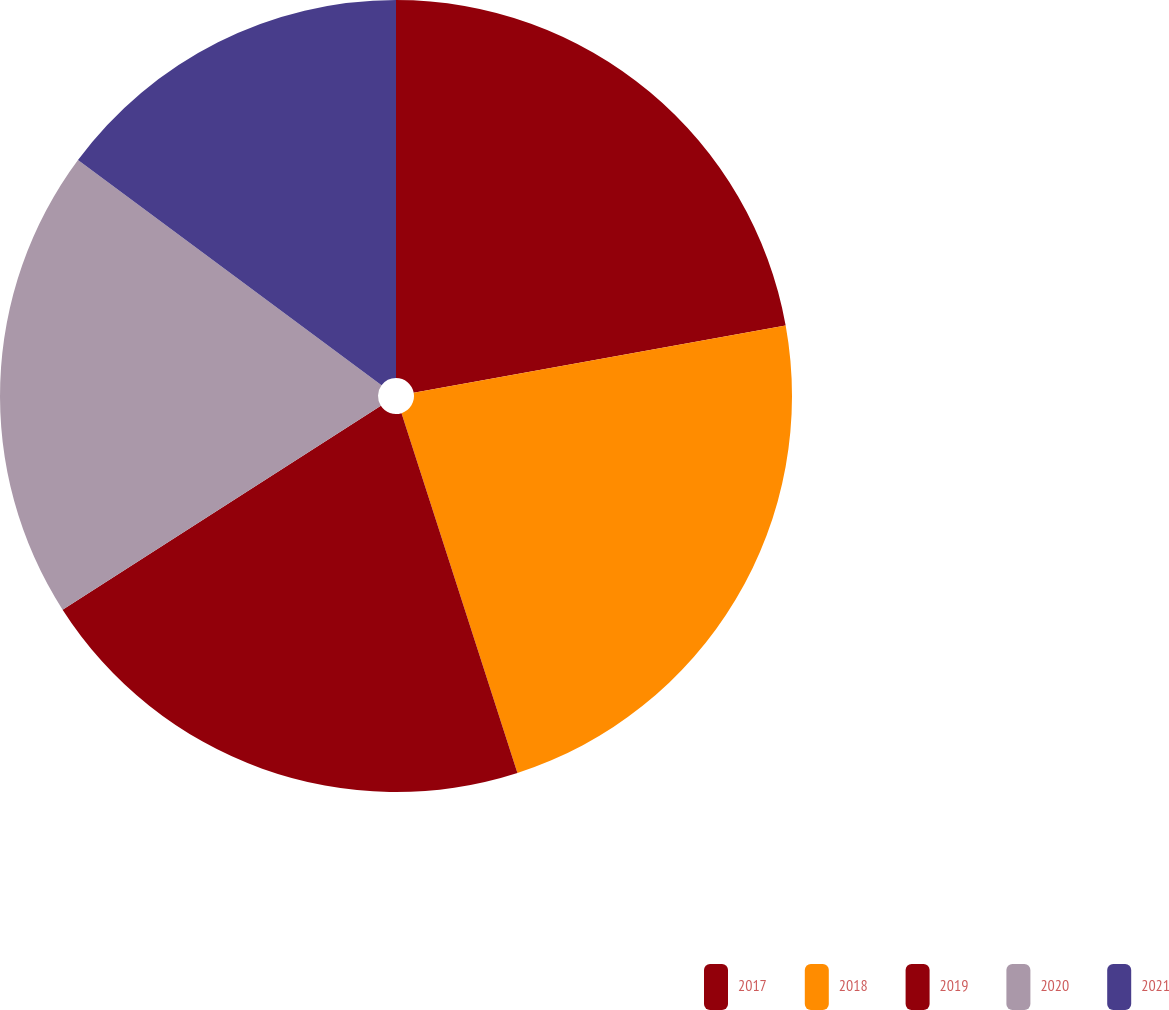Convert chart. <chart><loc_0><loc_0><loc_500><loc_500><pie_chart><fcel>2017<fcel>2018<fcel>2019<fcel>2020<fcel>2021<nl><fcel>22.15%<fcel>22.89%<fcel>20.89%<fcel>19.23%<fcel>14.84%<nl></chart> 